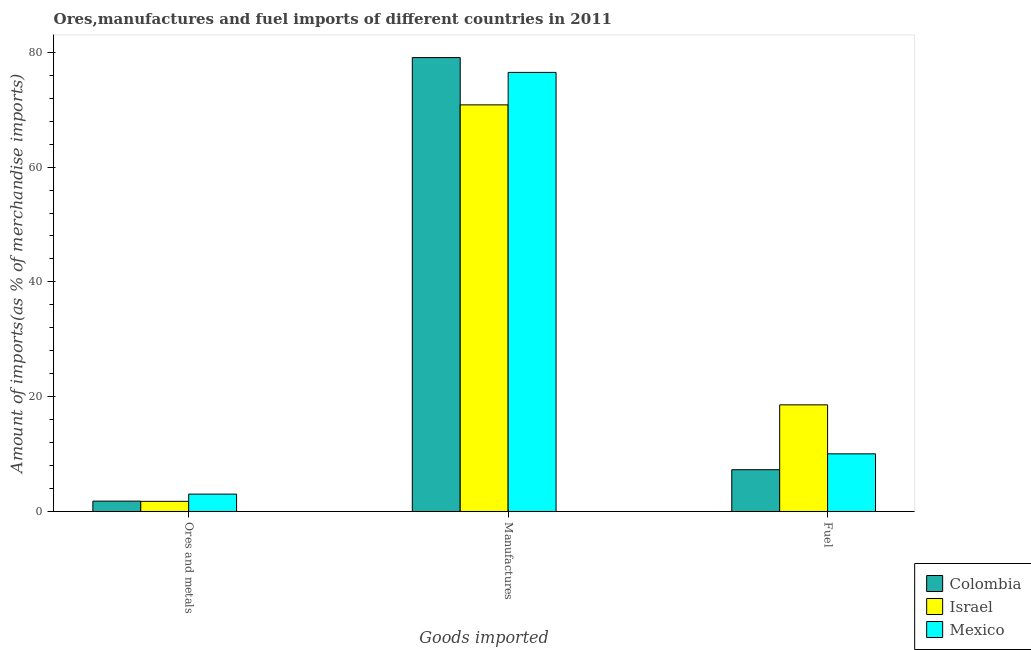How many different coloured bars are there?
Offer a very short reply. 3. How many groups of bars are there?
Ensure brevity in your answer.  3. How many bars are there on the 3rd tick from the right?
Ensure brevity in your answer.  3. What is the label of the 2nd group of bars from the left?
Your response must be concise. Manufactures. What is the percentage of manufactures imports in Mexico?
Ensure brevity in your answer.  76.5. Across all countries, what is the maximum percentage of ores and metals imports?
Provide a succinct answer. 3.03. Across all countries, what is the minimum percentage of manufactures imports?
Make the answer very short. 70.85. In which country was the percentage of fuel imports maximum?
Ensure brevity in your answer.  Israel. In which country was the percentage of fuel imports minimum?
Offer a very short reply. Colombia. What is the total percentage of ores and metals imports in the graph?
Ensure brevity in your answer.  6.6. What is the difference between the percentage of ores and metals imports in Israel and that in Colombia?
Make the answer very short. -0.04. What is the difference between the percentage of ores and metals imports in Colombia and the percentage of fuel imports in Israel?
Make the answer very short. -16.77. What is the average percentage of fuel imports per country?
Ensure brevity in your answer.  11.97. What is the difference between the percentage of ores and metals imports and percentage of manufactures imports in Colombia?
Offer a very short reply. -77.28. What is the ratio of the percentage of ores and metals imports in Mexico to that in Colombia?
Your answer should be compact. 1.68. What is the difference between the highest and the second highest percentage of manufactures imports?
Give a very brief answer. 2.58. What is the difference between the highest and the lowest percentage of manufactures imports?
Your answer should be very brief. 8.24. In how many countries, is the percentage of manufactures imports greater than the average percentage of manufactures imports taken over all countries?
Make the answer very short. 2. Is the sum of the percentage of fuel imports in Colombia and Israel greater than the maximum percentage of manufactures imports across all countries?
Your answer should be very brief. No. What does the 1st bar from the right in Manufactures represents?
Your response must be concise. Mexico. How many bars are there?
Your response must be concise. 9. Are all the bars in the graph horizontal?
Provide a short and direct response. No. Are the values on the major ticks of Y-axis written in scientific E-notation?
Offer a terse response. No. Does the graph contain any zero values?
Offer a very short reply. No. Does the graph contain grids?
Ensure brevity in your answer.  No. Where does the legend appear in the graph?
Provide a short and direct response. Bottom right. How many legend labels are there?
Provide a short and direct response. 3. What is the title of the graph?
Ensure brevity in your answer.  Ores,manufactures and fuel imports of different countries in 2011. What is the label or title of the X-axis?
Ensure brevity in your answer.  Goods imported. What is the label or title of the Y-axis?
Provide a short and direct response. Amount of imports(as % of merchandise imports). What is the Amount of imports(as % of merchandise imports) in Colombia in Ores and metals?
Your response must be concise. 1.81. What is the Amount of imports(as % of merchandise imports) in Israel in Ores and metals?
Provide a short and direct response. 1.77. What is the Amount of imports(as % of merchandise imports) of Mexico in Ores and metals?
Offer a terse response. 3.03. What is the Amount of imports(as % of merchandise imports) of Colombia in Manufactures?
Give a very brief answer. 79.08. What is the Amount of imports(as % of merchandise imports) in Israel in Manufactures?
Ensure brevity in your answer.  70.85. What is the Amount of imports(as % of merchandise imports) of Mexico in Manufactures?
Your response must be concise. 76.5. What is the Amount of imports(as % of merchandise imports) of Colombia in Fuel?
Offer a very short reply. 7.28. What is the Amount of imports(as % of merchandise imports) in Israel in Fuel?
Offer a very short reply. 18.58. What is the Amount of imports(as % of merchandise imports) of Mexico in Fuel?
Ensure brevity in your answer.  10.04. Across all Goods imported, what is the maximum Amount of imports(as % of merchandise imports) in Colombia?
Keep it short and to the point. 79.08. Across all Goods imported, what is the maximum Amount of imports(as % of merchandise imports) of Israel?
Give a very brief answer. 70.85. Across all Goods imported, what is the maximum Amount of imports(as % of merchandise imports) of Mexico?
Make the answer very short. 76.5. Across all Goods imported, what is the minimum Amount of imports(as % of merchandise imports) of Colombia?
Your answer should be very brief. 1.81. Across all Goods imported, what is the minimum Amount of imports(as % of merchandise imports) of Israel?
Your answer should be very brief. 1.77. Across all Goods imported, what is the minimum Amount of imports(as % of merchandise imports) of Mexico?
Your response must be concise. 3.03. What is the total Amount of imports(as % of merchandise imports) of Colombia in the graph?
Give a very brief answer. 88.17. What is the total Amount of imports(as % of merchandise imports) in Israel in the graph?
Provide a short and direct response. 91.19. What is the total Amount of imports(as % of merchandise imports) of Mexico in the graph?
Keep it short and to the point. 89.57. What is the difference between the Amount of imports(as % of merchandise imports) of Colombia in Ores and metals and that in Manufactures?
Your answer should be very brief. -77.28. What is the difference between the Amount of imports(as % of merchandise imports) in Israel in Ores and metals and that in Manufactures?
Your response must be concise. -69.08. What is the difference between the Amount of imports(as % of merchandise imports) in Mexico in Ores and metals and that in Manufactures?
Your answer should be very brief. -73.48. What is the difference between the Amount of imports(as % of merchandise imports) in Colombia in Ores and metals and that in Fuel?
Provide a short and direct response. -5.47. What is the difference between the Amount of imports(as % of merchandise imports) of Israel in Ores and metals and that in Fuel?
Make the answer very short. -16.81. What is the difference between the Amount of imports(as % of merchandise imports) of Mexico in Ores and metals and that in Fuel?
Provide a short and direct response. -7.02. What is the difference between the Amount of imports(as % of merchandise imports) of Colombia in Manufactures and that in Fuel?
Your answer should be compact. 71.81. What is the difference between the Amount of imports(as % of merchandise imports) in Israel in Manufactures and that in Fuel?
Your answer should be very brief. 52.27. What is the difference between the Amount of imports(as % of merchandise imports) in Mexico in Manufactures and that in Fuel?
Provide a short and direct response. 66.46. What is the difference between the Amount of imports(as % of merchandise imports) in Colombia in Ores and metals and the Amount of imports(as % of merchandise imports) in Israel in Manufactures?
Provide a succinct answer. -69.04. What is the difference between the Amount of imports(as % of merchandise imports) in Colombia in Ores and metals and the Amount of imports(as % of merchandise imports) in Mexico in Manufactures?
Make the answer very short. -74.7. What is the difference between the Amount of imports(as % of merchandise imports) in Israel in Ores and metals and the Amount of imports(as % of merchandise imports) in Mexico in Manufactures?
Make the answer very short. -74.73. What is the difference between the Amount of imports(as % of merchandise imports) in Colombia in Ores and metals and the Amount of imports(as % of merchandise imports) in Israel in Fuel?
Offer a terse response. -16.77. What is the difference between the Amount of imports(as % of merchandise imports) in Colombia in Ores and metals and the Amount of imports(as % of merchandise imports) in Mexico in Fuel?
Your response must be concise. -8.24. What is the difference between the Amount of imports(as % of merchandise imports) of Israel in Ores and metals and the Amount of imports(as % of merchandise imports) of Mexico in Fuel?
Keep it short and to the point. -8.27. What is the difference between the Amount of imports(as % of merchandise imports) of Colombia in Manufactures and the Amount of imports(as % of merchandise imports) of Israel in Fuel?
Give a very brief answer. 60.51. What is the difference between the Amount of imports(as % of merchandise imports) in Colombia in Manufactures and the Amount of imports(as % of merchandise imports) in Mexico in Fuel?
Offer a very short reply. 69.04. What is the difference between the Amount of imports(as % of merchandise imports) in Israel in Manufactures and the Amount of imports(as % of merchandise imports) in Mexico in Fuel?
Provide a succinct answer. 60.8. What is the average Amount of imports(as % of merchandise imports) of Colombia per Goods imported?
Your answer should be very brief. 29.39. What is the average Amount of imports(as % of merchandise imports) of Israel per Goods imported?
Keep it short and to the point. 30.4. What is the average Amount of imports(as % of merchandise imports) in Mexico per Goods imported?
Give a very brief answer. 29.86. What is the difference between the Amount of imports(as % of merchandise imports) of Colombia and Amount of imports(as % of merchandise imports) of Israel in Ores and metals?
Your answer should be very brief. 0.04. What is the difference between the Amount of imports(as % of merchandise imports) in Colombia and Amount of imports(as % of merchandise imports) in Mexico in Ores and metals?
Provide a short and direct response. -1.22. What is the difference between the Amount of imports(as % of merchandise imports) of Israel and Amount of imports(as % of merchandise imports) of Mexico in Ores and metals?
Offer a very short reply. -1.26. What is the difference between the Amount of imports(as % of merchandise imports) of Colombia and Amount of imports(as % of merchandise imports) of Israel in Manufactures?
Ensure brevity in your answer.  8.24. What is the difference between the Amount of imports(as % of merchandise imports) of Colombia and Amount of imports(as % of merchandise imports) of Mexico in Manufactures?
Provide a succinct answer. 2.58. What is the difference between the Amount of imports(as % of merchandise imports) in Israel and Amount of imports(as % of merchandise imports) in Mexico in Manufactures?
Ensure brevity in your answer.  -5.66. What is the difference between the Amount of imports(as % of merchandise imports) of Colombia and Amount of imports(as % of merchandise imports) of Israel in Fuel?
Offer a very short reply. -11.3. What is the difference between the Amount of imports(as % of merchandise imports) in Colombia and Amount of imports(as % of merchandise imports) in Mexico in Fuel?
Give a very brief answer. -2.76. What is the difference between the Amount of imports(as % of merchandise imports) in Israel and Amount of imports(as % of merchandise imports) in Mexico in Fuel?
Provide a short and direct response. 8.54. What is the ratio of the Amount of imports(as % of merchandise imports) of Colombia in Ores and metals to that in Manufactures?
Keep it short and to the point. 0.02. What is the ratio of the Amount of imports(as % of merchandise imports) of Israel in Ores and metals to that in Manufactures?
Keep it short and to the point. 0.03. What is the ratio of the Amount of imports(as % of merchandise imports) of Mexico in Ores and metals to that in Manufactures?
Your response must be concise. 0.04. What is the ratio of the Amount of imports(as % of merchandise imports) of Colombia in Ores and metals to that in Fuel?
Offer a terse response. 0.25. What is the ratio of the Amount of imports(as % of merchandise imports) of Israel in Ores and metals to that in Fuel?
Make the answer very short. 0.1. What is the ratio of the Amount of imports(as % of merchandise imports) in Mexico in Ores and metals to that in Fuel?
Your response must be concise. 0.3. What is the ratio of the Amount of imports(as % of merchandise imports) of Colombia in Manufactures to that in Fuel?
Provide a succinct answer. 10.87. What is the ratio of the Amount of imports(as % of merchandise imports) of Israel in Manufactures to that in Fuel?
Make the answer very short. 3.81. What is the ratio of the Amount of imports(as % of merchandise imports) of Mexico in Manufactures to that in Fuel?
Your answer should be very brief. 7.62. What is the difference between the highest and the second highest Amount of imports(as % of merchandise imports) in Colombia?
Make the answer very short. 71.81. What is the difference between the highest and the second highest Amount of imports(as % of merchandise imports) in Israel?
Your response must be concise. 52.27. What is the difference between the highest and the second highest Amount of imports(as % of merchandise imports) of Mexico?
Provide a succinct answer. 66.46. What is the difference between the highest and the lowest Amount of imports(as % of merchandise imports) in Colombia?
Your answer should be very brief. 77.28. What is the difference between the highest and the lowest Amount of imports(as % of merchandise imports) of Israel?
Make the answer very short. 69.08. What is the difference between the highest and the lowest Amount of imports(as % of merchandise imports) in Mexico?
Ensure brevity in your answer.  73.48. 